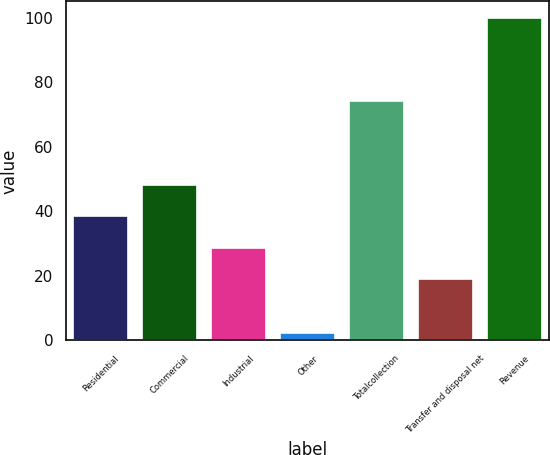Convert chart. <chart><loc_0><loc_0><loc_500><loc_500><bar_chart><fcel>Residential<fcel>Commercial<fcel>Industrial<fcel>Other<fcel>Totalcollection<fcel>Transfer and disposal net<fcel>Revenue<nl><fcel>38.44<fcel>48.21<fcel>28.67<fcel>2.3<fcel>74.3<fcel>18.9<fcel>100<nl></chart> 